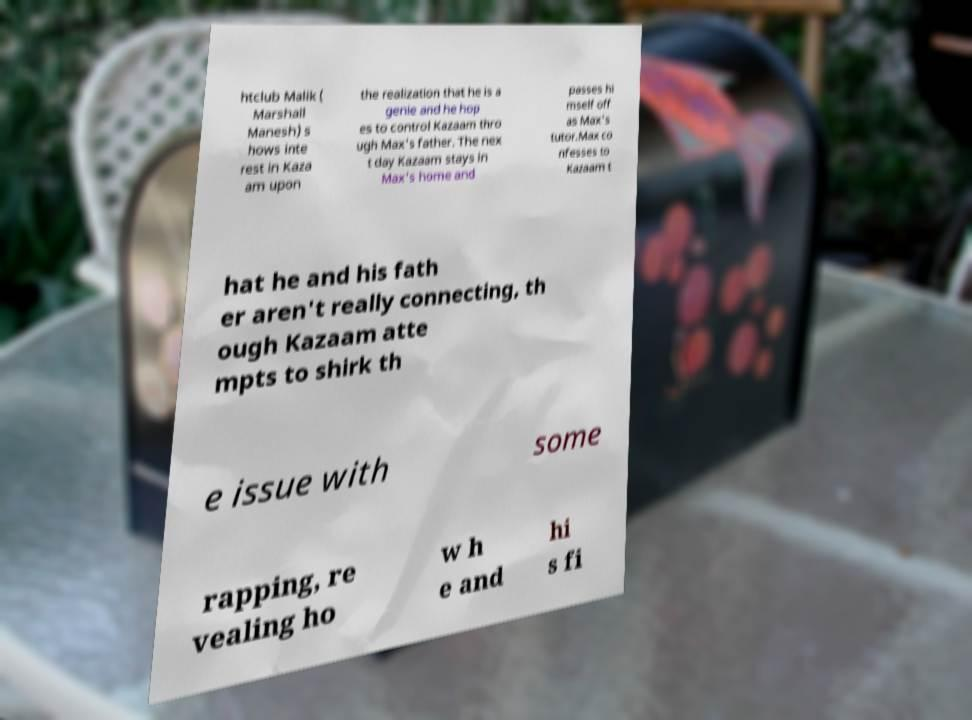Could you assist in decoding the text presented in this image and type it out clearly? htclub Malik ( Marshall Manesh) s hows inte rest in Kaza am upon the realization that he is a genie and he hop es to control Kazaam thro ugh Max's father. The nex t day Kazaam stays in Max's home and passes hi mself off as Max's tutor.Max co nfesses to Kazaam t hat he and his fath er aren't really connecting, th ough Kazaam atte mpts to shirk th e issue with some rapping, re vealing ho w h e and hi s fi 